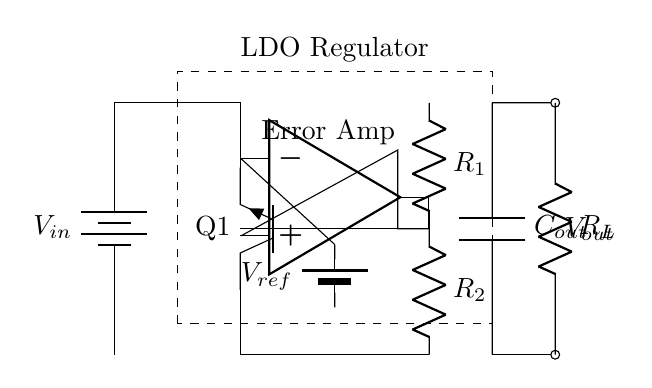What is the input voltage of the circuit? The input voltage is labeled as V_in in the diagram, which represents the voltage supplied to the regulator.
Answer: V_in What type of transistor is used as the pass element? The transistor depicted in the circuit is labeled as Q1 and is shown as a Tnpn, indicating it is a NPN transistor.
Answer: NPN How many resistors are present in the feedback network? The circuit shows two resistors labeled R1 and R2 connected in series, making a total of two resistors in the feedback network.
Answer: 2 What is the purpose of the error amplifier? The error amplifier, represented in the circuit as an op amp, is used to compare the output voltage with a reference voltage to regulate the output.
Answer: Regulation What connects the output capacitor to the load? The output capacitor, labeled as C_out, connects directly to the load resistor R_L via a short circuit line, indicating flow to the load.
Answer: Short circuit What is the voltage reference in the circuit? The voltage reference is indicated in the circuit as V_ref, which is used by the error amplifier to set the desired output voltage level.
Answer: V_ref What is the output voltage of the regulator? The output voltage is labeled as V_out, representing the voltage delivered to the load across R_L, which is regulated by the circuit.
Answer: V_out 